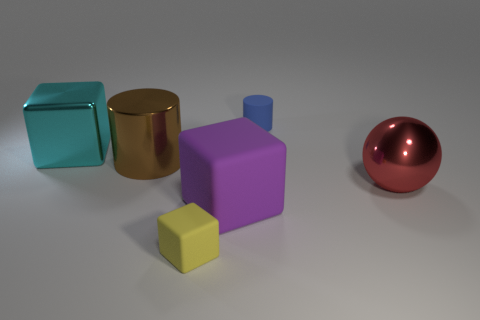Add 1 tiny yellow blocks. How many objects exist? 7 Subtract all cylinders. How many objects are left? 4 Subtract all yellow things. Subtract all large purple objects. How many objects are left? 4 Add 3 big red things. How many big red things are left? 4 Add 3 large brown metallic objects. How many large brown metallic objects exist? 4 Subtract 1 purple blocks. How many objects are left? 5 